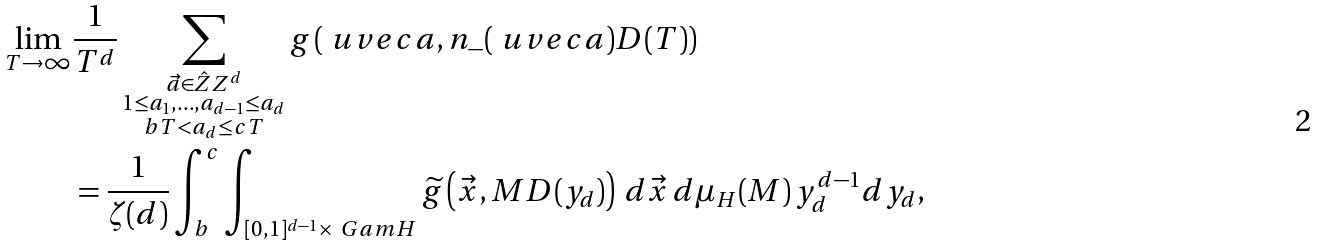Convert formula to latex. <formula><loc_0><loc_0><loc_500><loc_500>\lim _ { T \to \infty } & \frac { 1 } { T ^ { d } } \sum _ { \substack { \vec { a } \in \hat { Z } Z ^ { d } \\ 1 \leq a _ { 1 } , \dots , a _ { d - 1 } \leq a _ { d } \\ b T < a _ { d } \leq c T } } g \left ( \ u v e c a , n _ { - } ( \ u v e c a ) D ( T ) \right ) \\ & = \frac { 1 } { \zeta ( d ) } \int _ { b } ^ { c } \int _ { [ 0 , 1 ] ^ { d - 1 } \times \ G a m H } \widetilde { g } \left ( \vec { x } , M D ( y _ { d } ) \right ) \, d \vec { x } \, d \mu _ { H } ( M ) \, y _ { d } ^ { d - 1 } d y _ { d } ,</formula> 